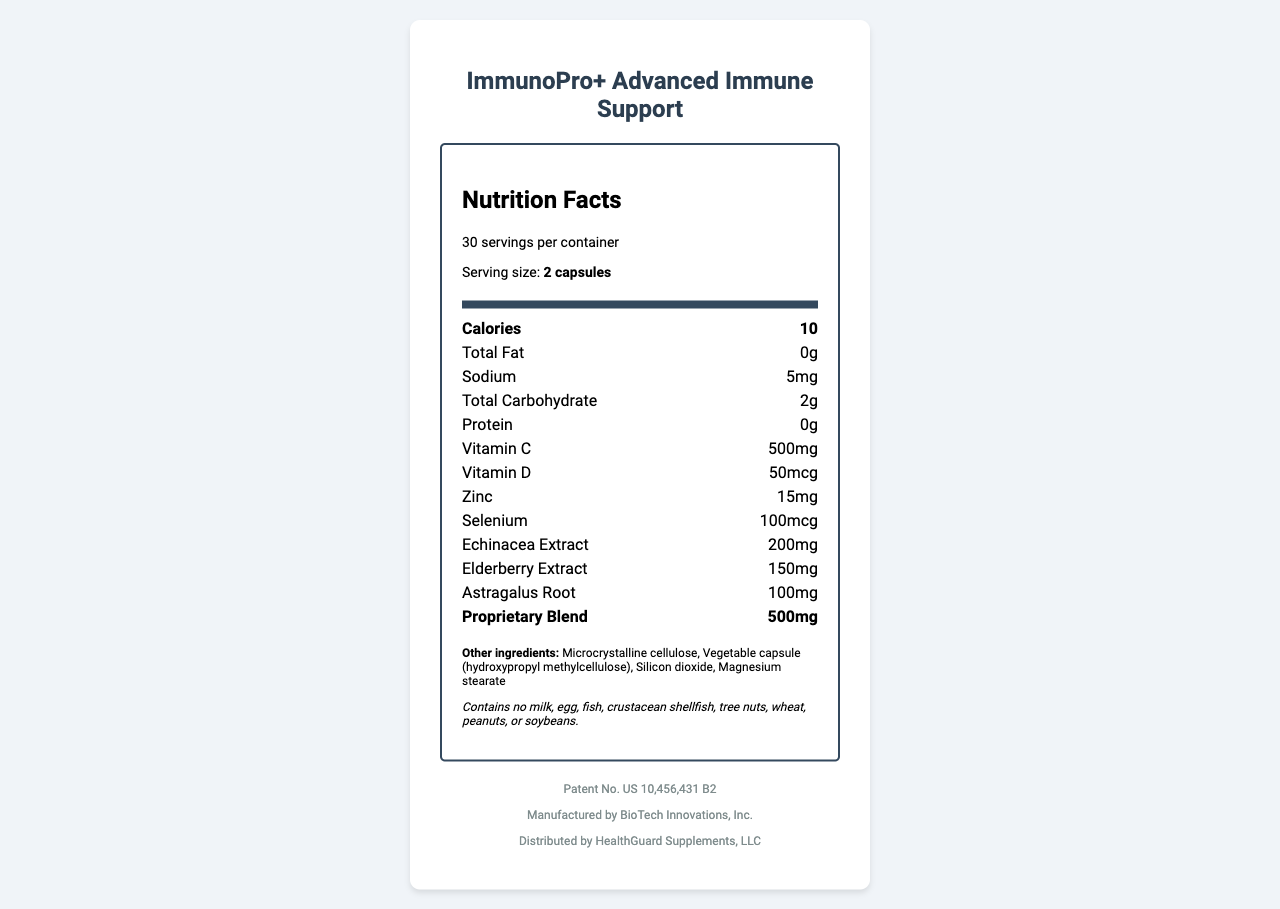what is the serving size for ImmunoPro+ Advanced Immune Support? The document specifies the serving size as "2 capsules" in the summary of the supplement information.
Answer: 2 capsules how many servings are there per container? The label states "30 servings per container" clearly in the document.
Answer: 30 servings what is the amount of Vitamin C per serving? The Nutrition Facts section lists "Vitamin C: 500mg".
Answer: 500mg who is the expert witness for the plaintiff? The document states that the expert witness is Dr. Emily Thornton, who has a Ph.D. in Nutritional Sciences.
Answer: Dr. Emily Thornton what are the alleged infringements in the lawsuit? The lawsuit details mention that the alleged infringement includes unauthorized use of a patented formula and similar packaging design.
Answer: Unauthorized use of patented formula and similar packaging design with how many total calories is each serving of this health supplement? The total calories per serving are specified as "10" in the Nutrition Facts section.
Answer: 10 calories what is the amount of sodium present in each serving? The Nutrition Facts section lists "Sodium: 5mg".
Answer: 5mg what is the total amount of the proprietary blend in one serving? A. 200mg B. 500mg C. 100mg D. 150mg The document specifies the proprietary blend amount as "500mg".
Answer: B. 500mg which of the following is not an ingredient in ImmunoPro+? 1. Microcrystalline cellulose 2. Silicon dioxide 3. Echinacea extract 4. L-Carnitine The list of ingredients includes Microcrystalline cellulose, Silicon dioxide, and Echinacea extract but does not mention L-Carnitine.
Answer: 4. L-Carnitine is there any milk allergen present in this supplement? The document specifies that it contains no milk, egg, fish, crustacean shellfish, tree nuts, wheat, peanuts, or soybeans.
Answer: No please summarize the main information included in this document. The document includes the Nutrition Facts label for a health supplement, explaining its nutritional content, ingredients, allergen warnings, and details about a lawsuit regarding patent infringement.
Answer: The document is a Nutrition Facts label for "ImmunoPro+ Advanced Immune Support," a health supplement manufactured by BioTech Innovations, Inc. and distributed by HealthGuard Supplements, LLC. It provides detailed nutritional information, the list of ingredients, allergen information, patent number, along with details regarding a lawsuit where BioTech Innovations, Inc. alleges NaturalLife Wellness Co. of infringing its patented formula and similar packaging design. The expert witness for the plaintiff is Dr. Emily Thornton. The financial impact of the infringement is estimated with potential damages of $15.6 million. what was the date when the product was patented? The document provides the patent number (US 10,456,431 B2) but does not specify the date when the patent was filed or granted.
Answer: Cannot be determined 